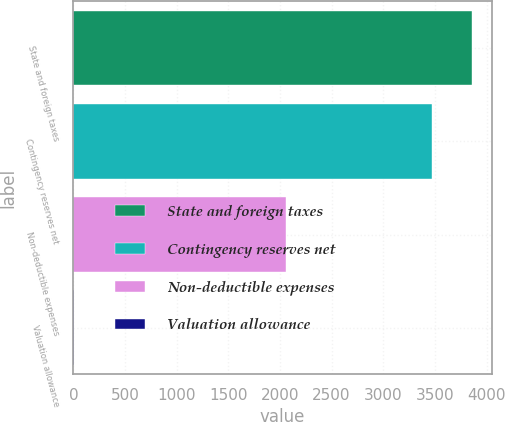Convert chart to OTSL. <chart><loc_0><loc_0><loc_500><loc_500><bar_chart><fcel>State and foreign taxes<fcel>Contingency reserves net<fcel>Non-deductible expenses<fcel>Valuation allowance<nl><fcel>3858.9<fcel>3476<fcel>2054<fcel>8<nl></chart> 